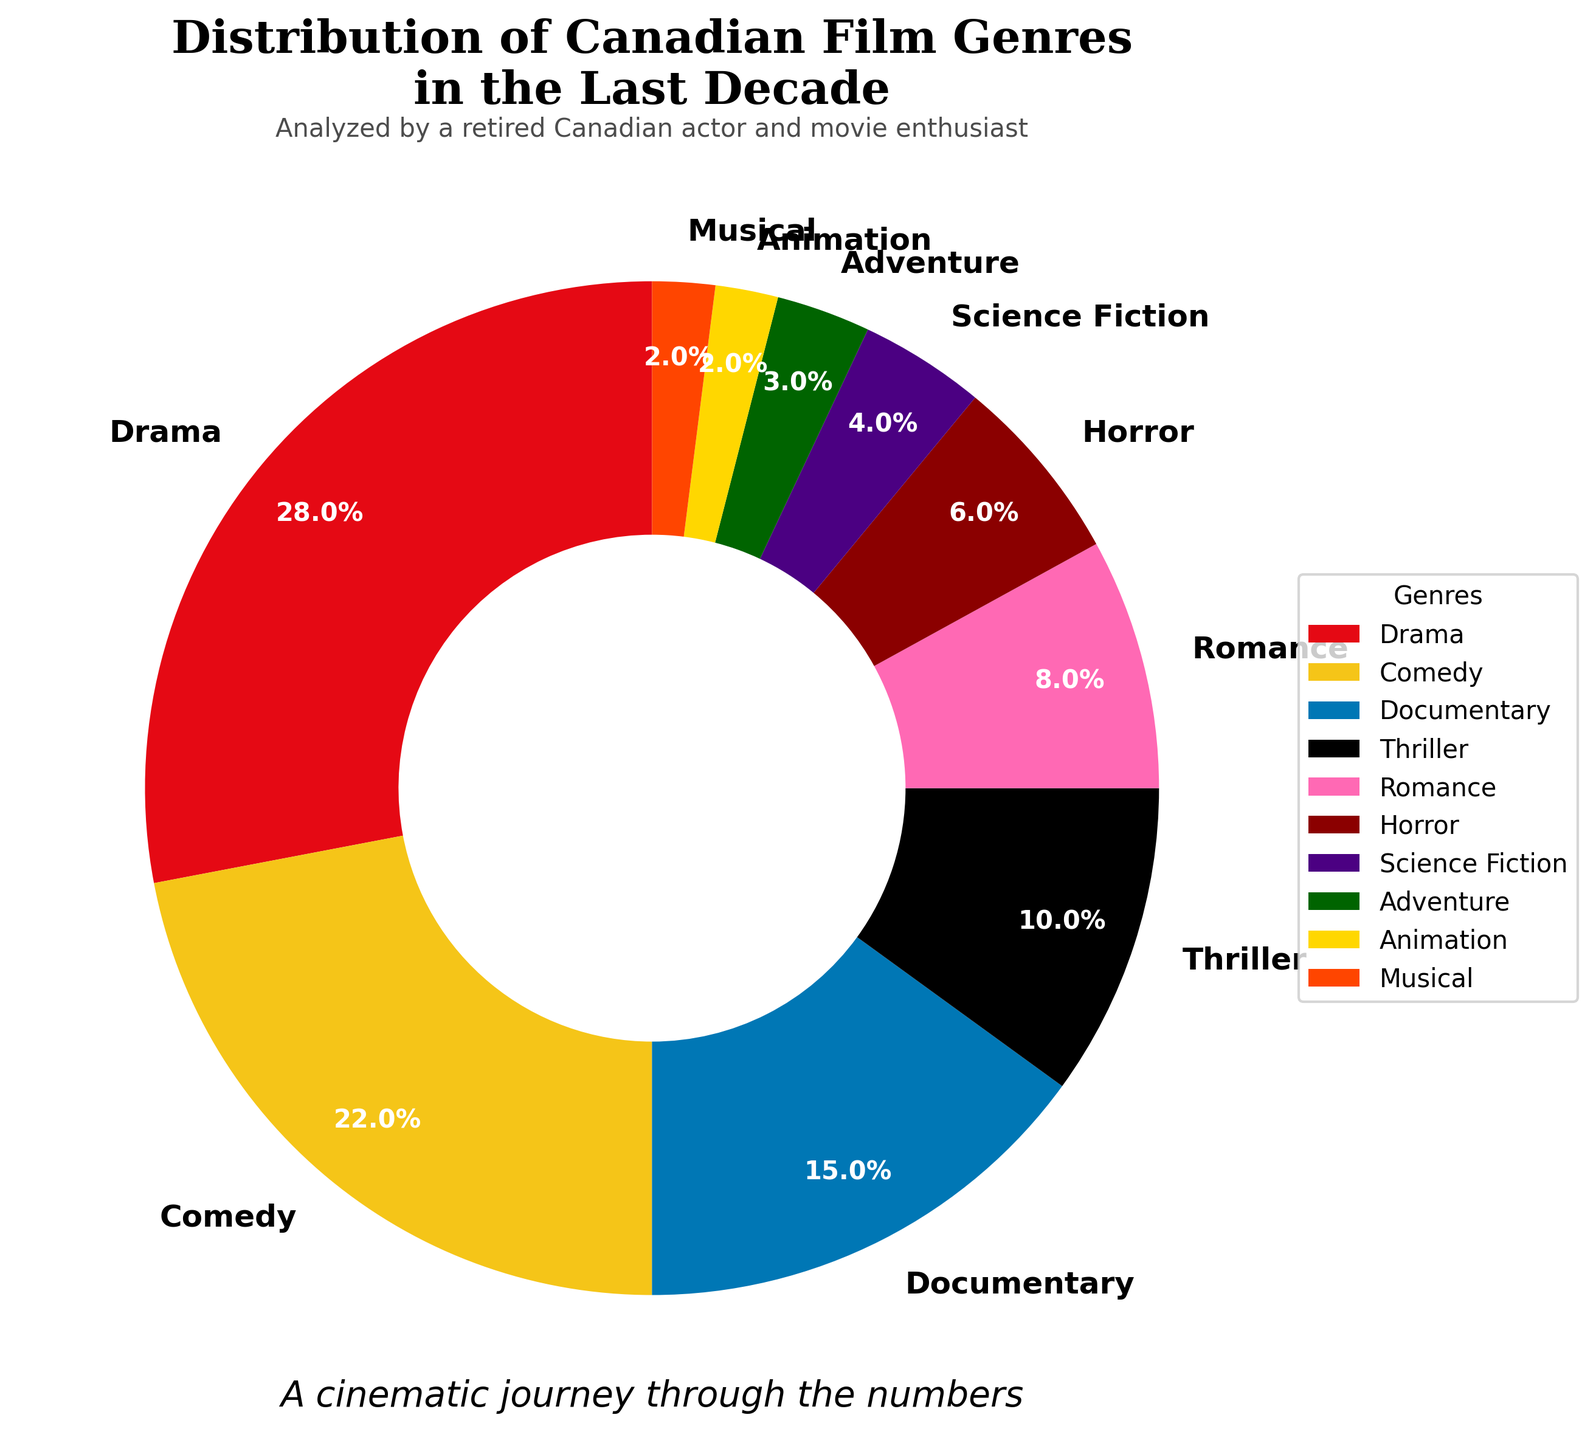Which genre has the highest percentage of films produced? Looking at the pie chart, Drama has the largest section, marked clearly by its prominent size.
Answer: Drama Which genre has the smallest percentage of films produced? The genres Animation and Musical have the smallest sections of the pie chart, showing the least percentage.
Answer: Animation and Musical By how many percentage points does Drama surpass Comedy in the film production distribution? Drama holds 28% while Comedy holds 22%. Subtracting these values gives 28% - 22% = 6%.
Answer: 6 percentage points What is the total percentage of films produced for Documentary, Horror, and Science Fiction genres combined? Documentary is 15%, Horror is 6%, and Science Fiction is 4%. Adding them gives 15% + 6% + 4% = 25%.
Answer: 25% Which genre produced less: Science Fiction or Adventure? Comparing the sections of the pie chart, Science Fiction is at 4%, and Adventure is at 3%.
Answer: Adventure If the total number of films produced is 500, how many films fall under the Comedy genre? Comedy holds 22% of 500 films. Calculating this gives 0.22 * 500 = 110 films.
Answer: 110 films What is the combined percentage of Thrillers and Romances? Thriller is 10% and Romance is 8%. Adding them gives 10% + 8% = 18%.
Answer: 18% Which genres make up one-fifth of the total film production combined? One-fifth translates to 20%. Comedy is 22%, slightly above, but Horror at 6% and Science Fiction at 4% combine to 10%, which don't reach 20%. Documentary at 15% and Adventure at 3% sum to 18%, Horror 6% and Romance 8% make 14%, which leaves no exact fit. Thus, no two genres fit exactly into one-fifth.
Answer: No exact fit Considering the visual attributes, what is the color used for the Drama genre in the pie chart? The Drama genre is represented by a prominent section colored in red on the chart.
Answer: Red 